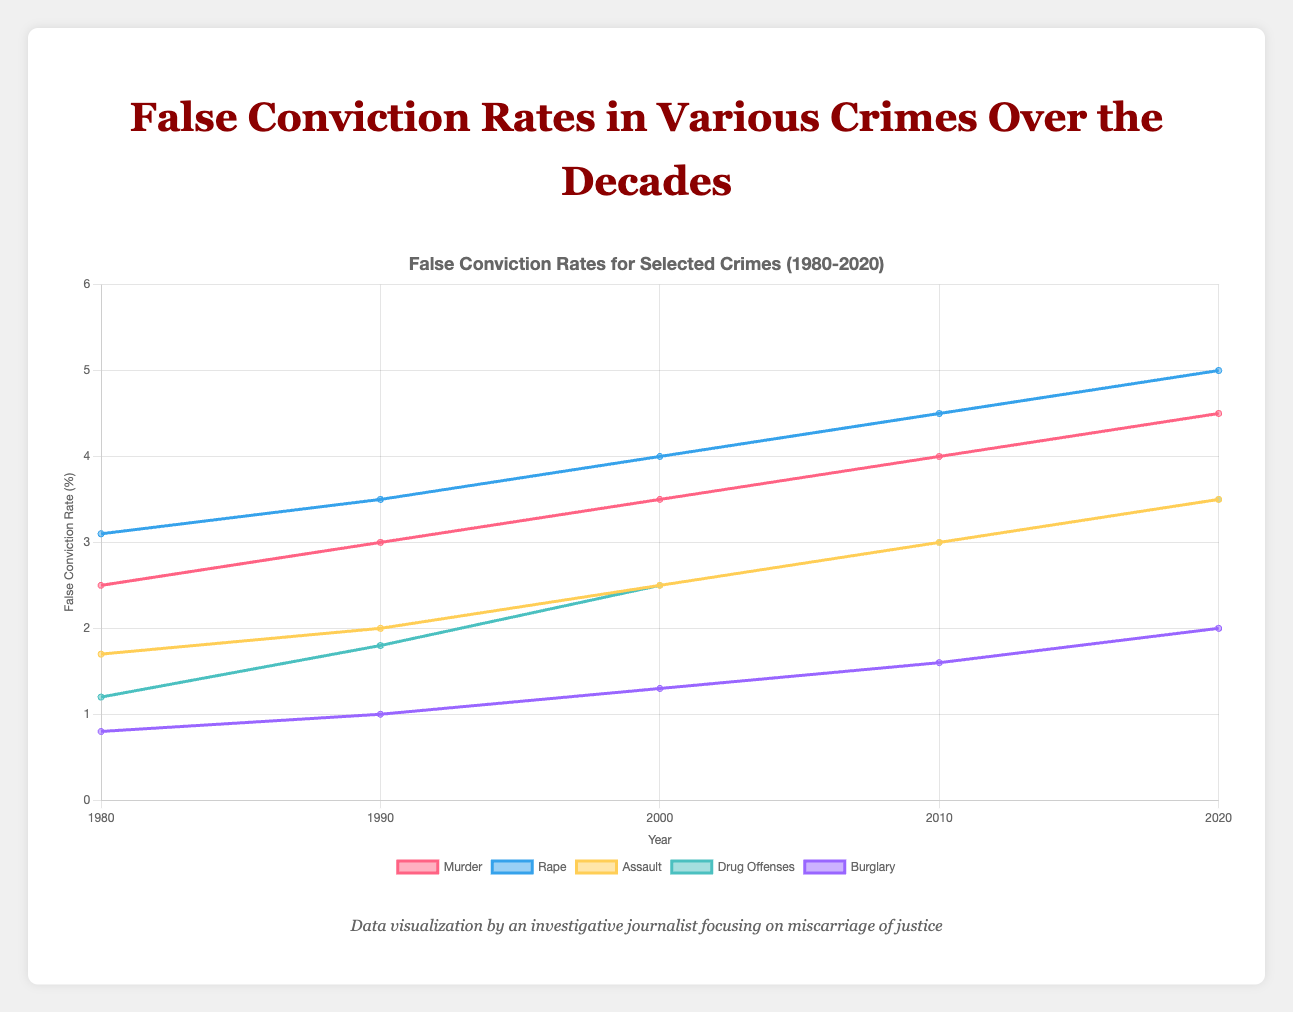What has the trend in the false conviction rate for murder been from 1980 to 2020? The false conviction rate for murder has shown a consistent increase over the decades. Specifically, it increased from 2.5% in 1980 to 4.5% in 2020.
Answer: Consistent increase Which crime showed the highest false conviction rate in 2020? By examining the plot, rape had the highest false conviction rate in 2020 with a rate of 5.0%.
Answer: Rape Compare the false conviction rates for drug offenses and burglary in 2010. Which one was higher? Drug offenses had a false conviction rate of 3.0%, whereas burglary had a false conviction rate of 1.6% in 2010. Therefore, drug offenses had a higher false conviction rate.
Answer: Drug offenses What is the difference in the false conviction rates for rape between 1980 and 2020? The false conviction rate for rape in 1980 was 3.1%, and it increased to 5.0% in 2020. The difference is 5.0% - 3.1% = 1.9%.
Answer: 1.9% Identify the crime with the lowest false conviction rate in 2000 and provide the rate. Public drunkenness had the lowest false conviction rate in 2000, with a rate of 0.8%.
Answer: Public drunkenness, 0.8% By how much did the false conviction rate for assault increase from 1990 to 2010? The false conviction rate for assault was 2.0% in 1990 and increased to 3.0% in 2010. The increase is 3.0% - 2.0% = 1.0%.
Answer: 1.0% Which crime had a higher false conviction rate in 1990: motor vehicle theft or public drunkenness? In 1990, the false conviction rate for motor vehicle theft was 0.9%, while public drunkenness had a rate of 0.6%. Therefore, motor vehicle theft had a higher rate.
Answer: Motor vehicle theft Calculate the average false conviction rate for public order crimes in 1980. The false conviction rates for public order crimes in 1980 are drug offenses (1.2%), prostitution (0.9%), and public drunkenness (0.4%). The average rate is (1.2% + 0.9% + 0.4%)/3 = 0.833%.
Answer: 0.833% Compare the trend in false conviction rates for larceny and motor vehicle theft from 1980 to 2020. Both larceny and motor vehicle theft show an increasing trend from 1980 to 2020. Larceny increased from 0.5% to 1.5%, and motor vehicle theft increased from 0.6% to 1.8%.
Answer: Both increased What color represents the false conviction rates for burglary in the plot, and how does the height of the line compare to that for larceny in 2000? Burglary is represented by a purple line. In 2000, the height of the burglary line is taller than the height of the larceny line, indicating a higher false conviction rate for burglary (1.3%) compared to larceny (0.9%).
Answer: Purple, taller for burglary 